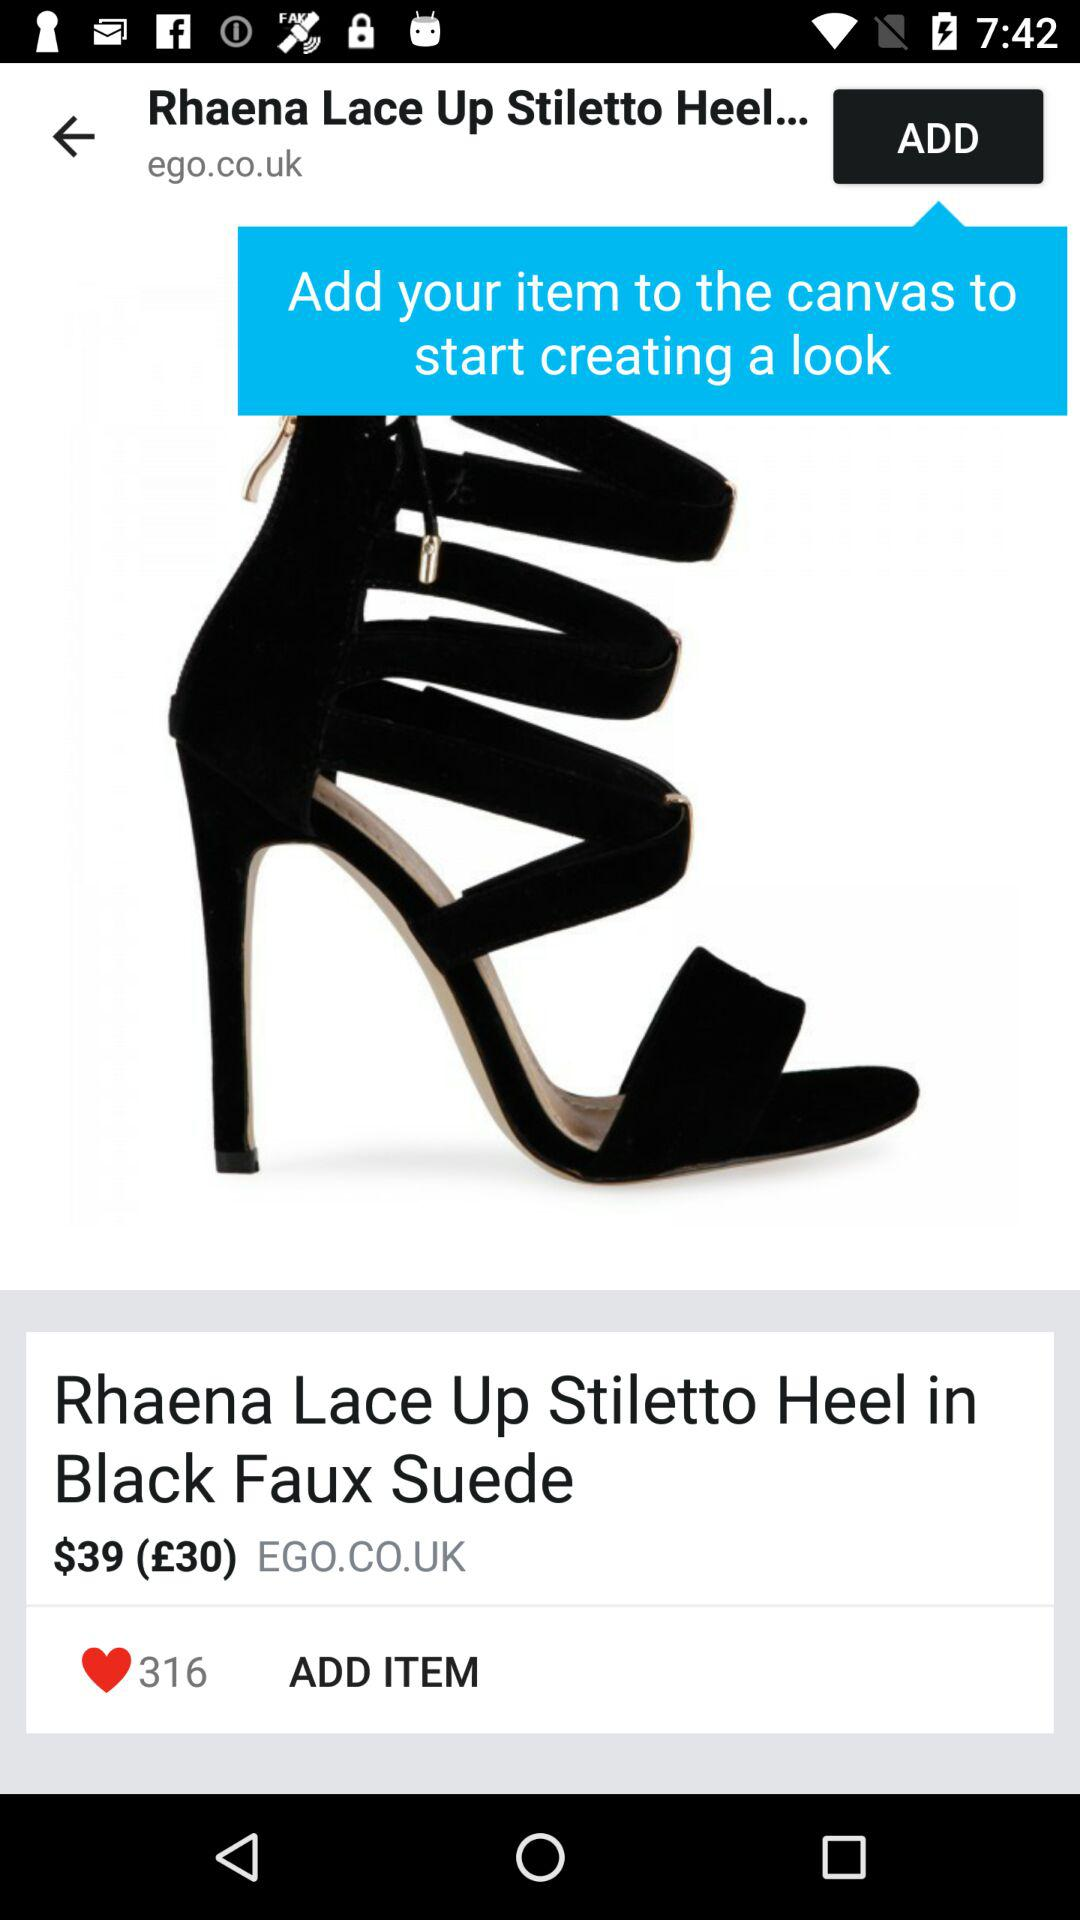What is the price of the item?
Answer the question using a single word or phrase. $39 (£30) 